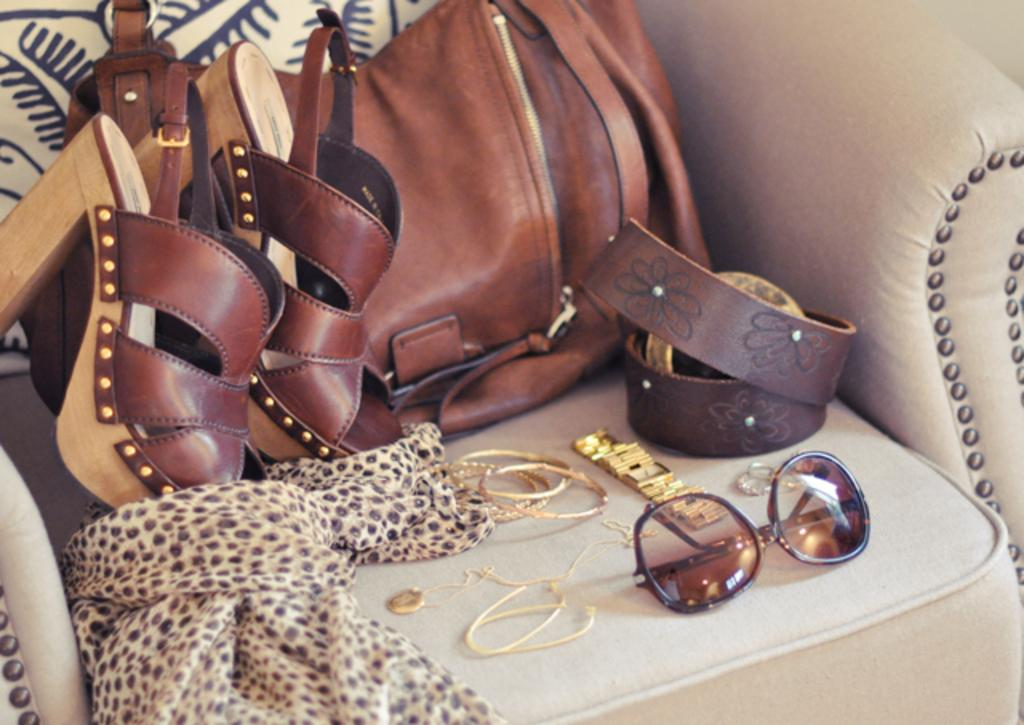What type of footwear is placed on the chair in the image? There are sandals on a chair in the image. What other items can be seen on the chair? There is a bag, a belt, goggles, a bangle, a watch, a chain, and a scarf on the chair. What type of approval does the grandmother give in the image? There is no grandmother present in the image, nor is there any indication of approval. 